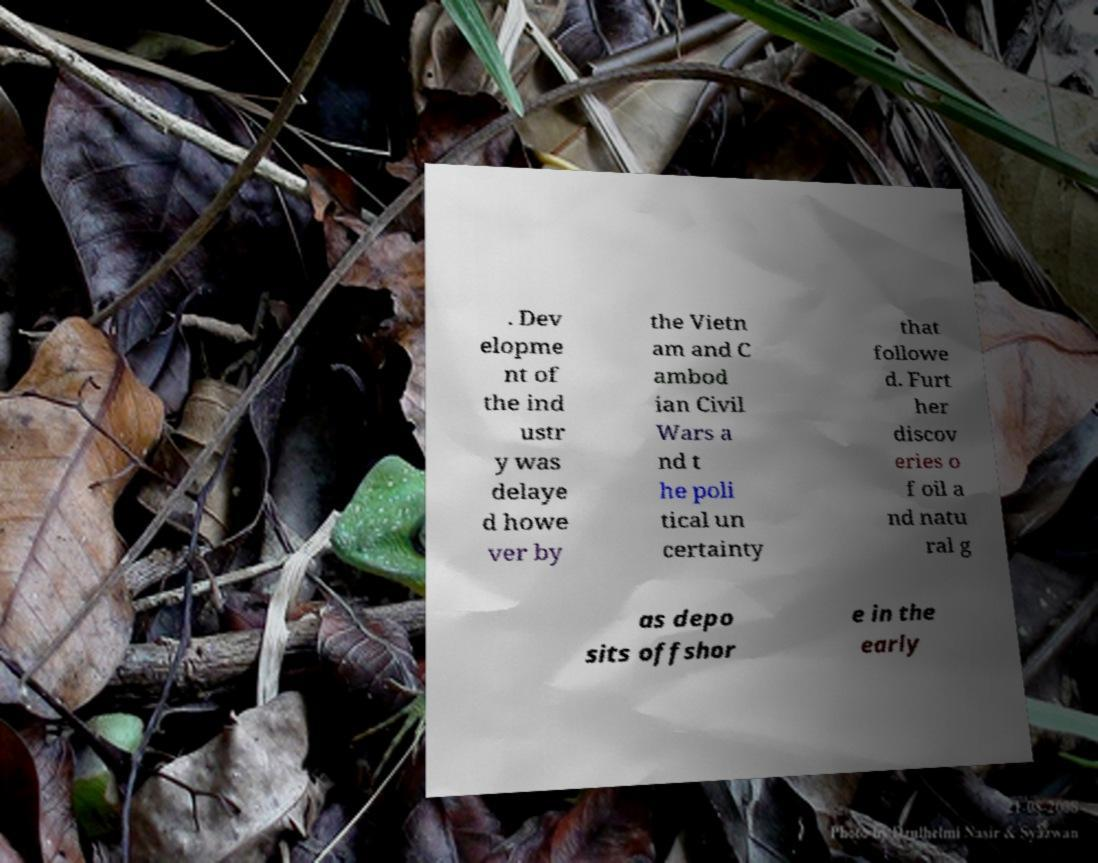Could you assist in decoding the text presented in this image and type it out clearly? . Dev elopme nt of the ind ustr y was delaye d howe ver by the Vietn am and C ambod ian Civil Wars a nd t he poli tical un certainty that followe d. Furt her discov eries o f oil a nd natu ral g as depo sits offshor e in the early 